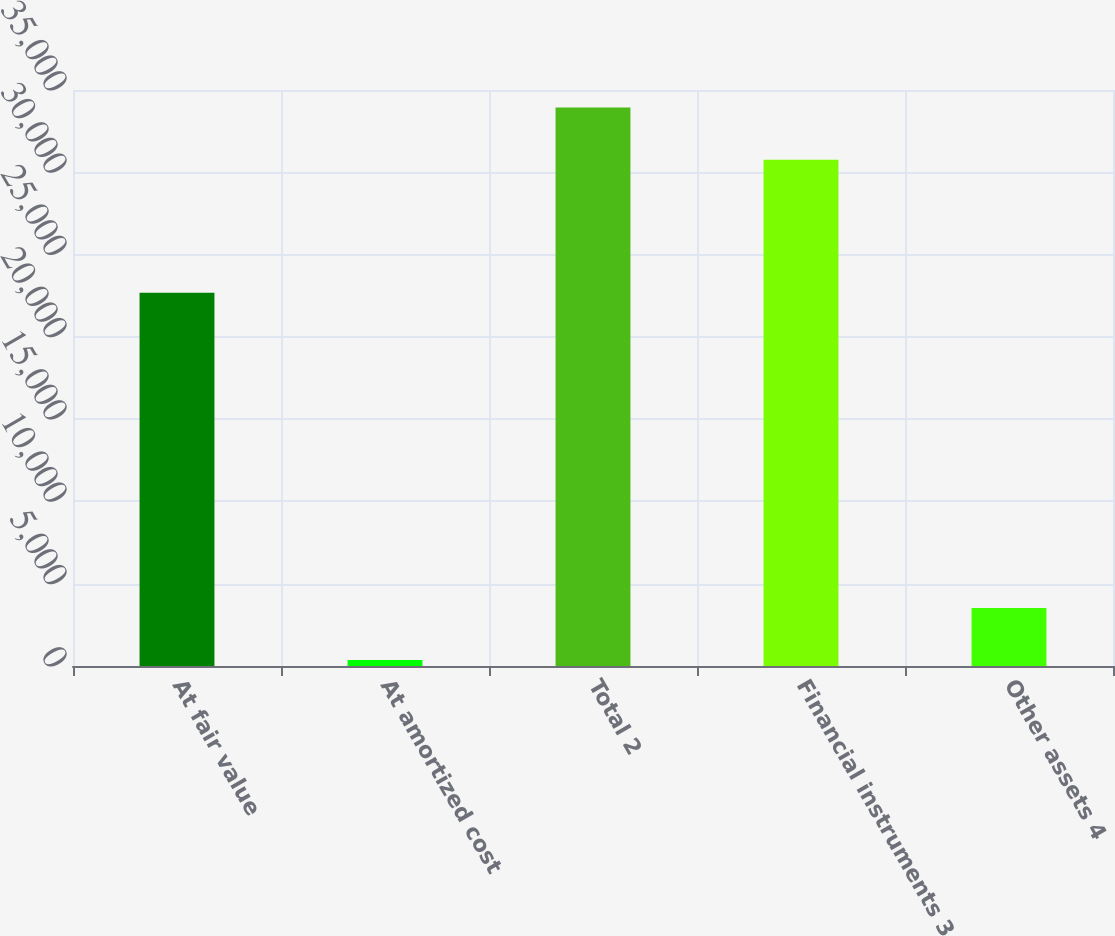<chart> <loc_0><loc_0><loc_500><loc_500><bar_chart><fcel>At fair value<fcel>At amortized cost<fcel>Total 2<fcel>Financial instruments 3<fcel>Other assets 4<nl><fcel>22685<fcel>360<fcel>33930<fcel>30765<fcel>3525<nl></chart> 